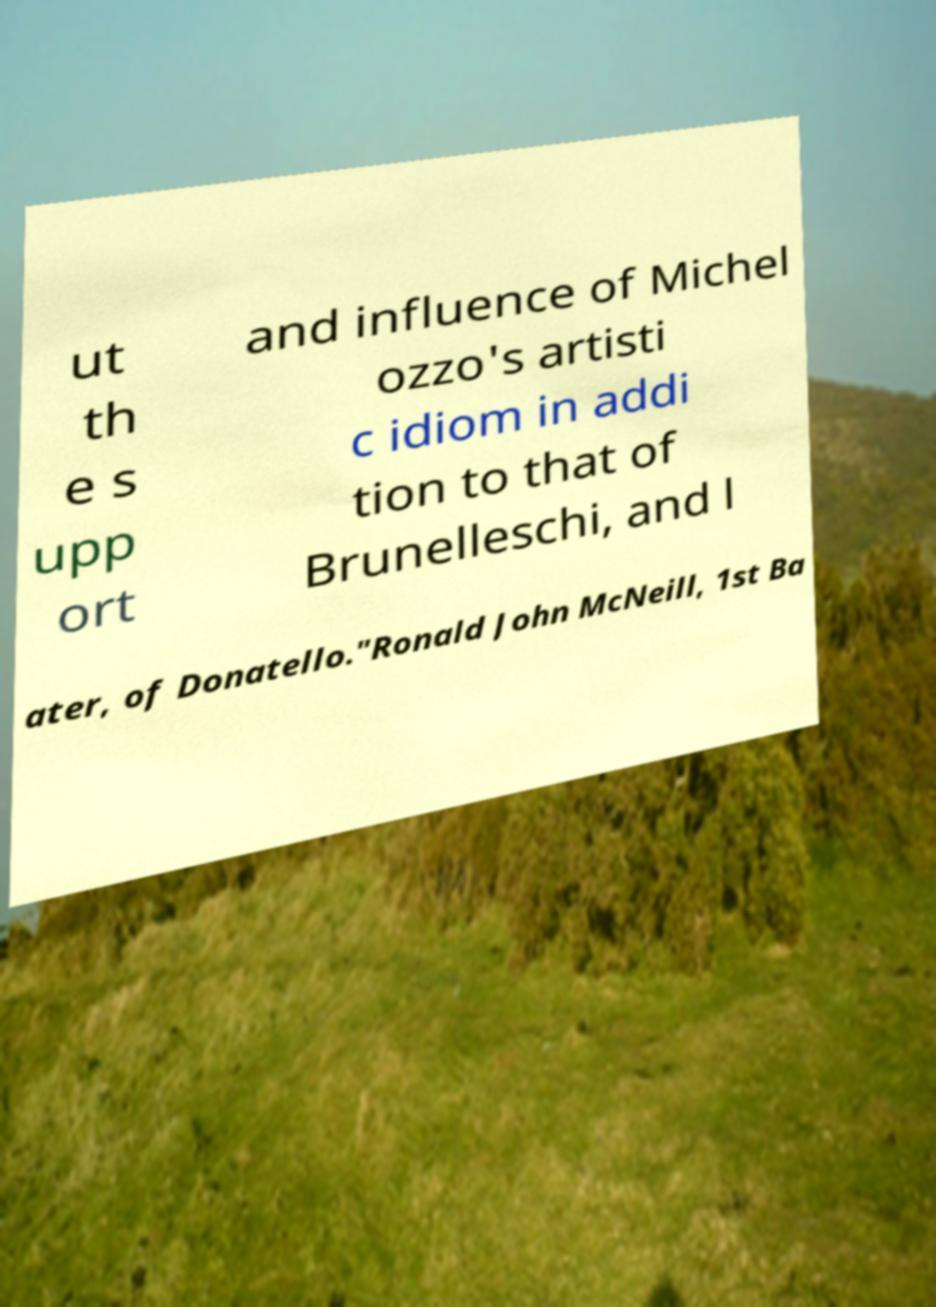Can you read and provide the text displayed in the image?This photo seems to have some interesting text. Can you extract and type it out for me? ut th e s upp ort and influence of Michel ozzo's artisti c idiom in addi tion to that of Brunelleschi, and l ater, of Donatello."Ronald John McNeill, 1st Ba 